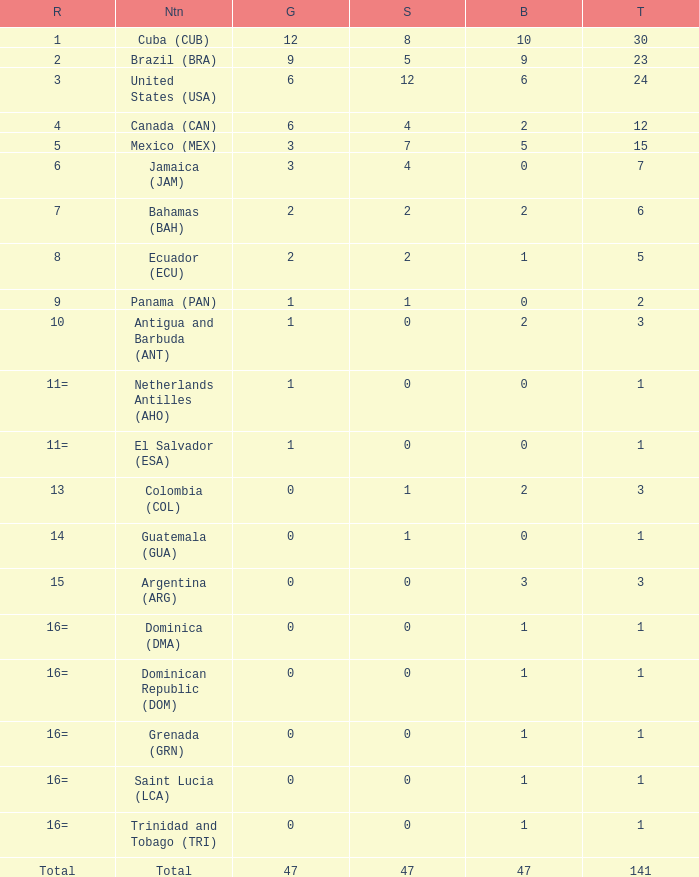What is the average silver with more than 0 gold, a Rank of 1, and a Total smaller than 30? None. 